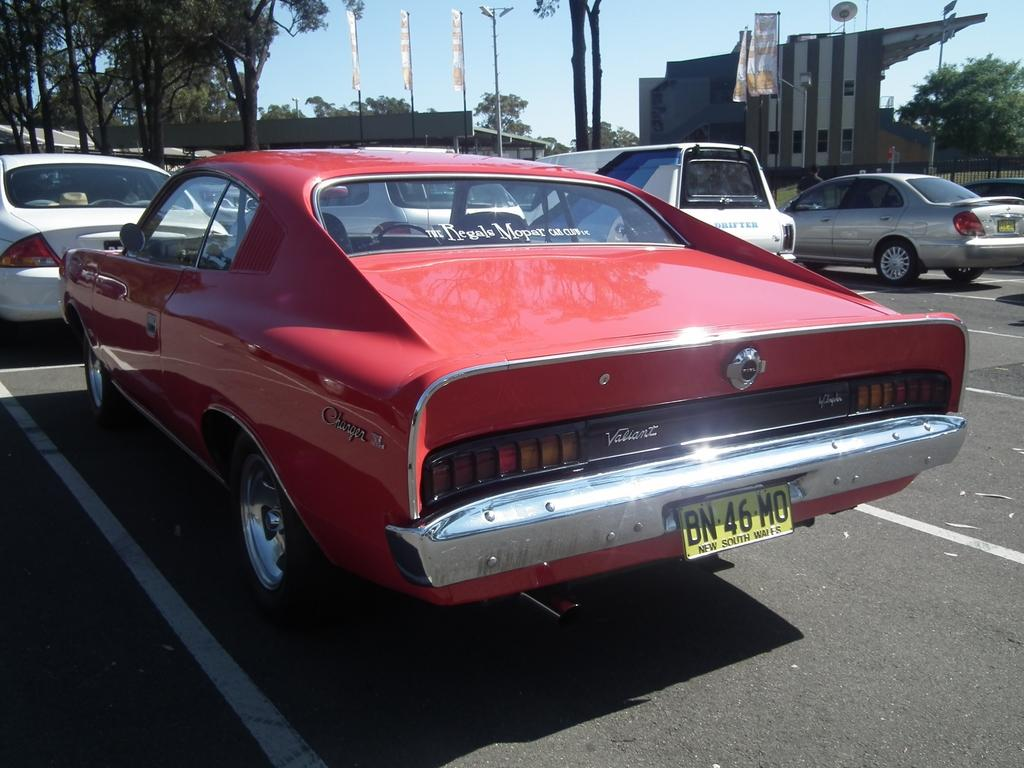<image>
Describe the image concisely. a license plate that has the letters BN on the back of it 